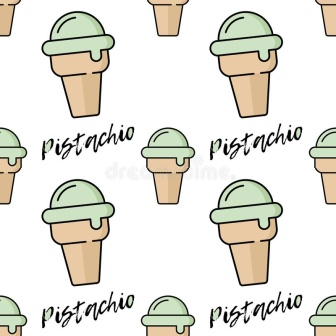How would you describe this image to someone who cannot see it? This image features a repeated pattern of pistachio ice cream cones, arranged in a neat grid. Each cone is a light brown color and holds a vibrant green scoop of pistachio ice cream on top. The cones are evenly spaced in four rows and three columns, creating a total of twelve cones. Above and below each cone, the word 'Pistachio' is written in bold black, stylish script, emphasizing the flavor of the ice cream. The overall effect creates a visually pleasing and rhythmic pattern, with a clean and simple yet captivating design. 